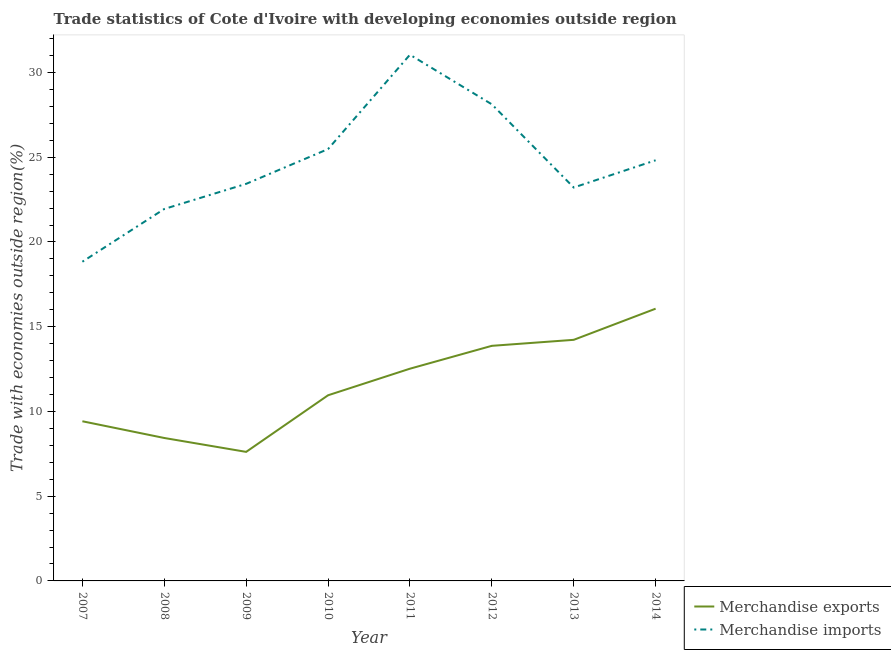How many different coloured lines are there?
Give a very brief answer. 2. Does the line corresponding to merchandise imports intersect with the line corresponding to merchandise exports?
Provide a succinct answer. No. Is the number of lines equal to the number of legend labels?
Offer a very short reply. Yes. What is the merchandise exports in 2007?
Provide a succinct answer. 9.42. Across all years, what is the maximum merchandise exports?
Give a very brief answer. 16.06. Across all years, what is the minimum merchandise imports?
Offer a very short reply. 18.84. In which year was the merchandise imports maximum?
Give a very brief answer. 2011. What is the total merchandise exports in the graph?
Make the answer very short. 93.11. What is the difference between the merchandise imports in 2007 and that in 2012?
Your response must be concise. -9.29. What is the difference between the merchandise imports in 2010 and the merchandise exports in 2011?
Keep it short and to the point. 12.96. What is the average merchandise exports per year?
Your answer should be compact. 11.64. In the year 2008, what is the difference between the merchandise imports and merchandise exports?
Your answer should be compact. 13.51. What is the ratio of the merchandise imports in 2010 to that in 2011?
Make the answer very short. 0.82. Is the difference between the merchandise imports in 2007 and 2010 greater than the difference between the merchandise exports in 2007 and 2010?
Provide a succinct answer. No. What is the difference between the highest and the second highest merchandise imports?
Your answer should be very brief. 2.93. What is the difference between the highest and the lowest merchandise imports?
Your response must be concise. 12.21. In how many years, is the merchandise imports greater than the average merchandise imports taken over all years?
Offer a terse response. 4. Is the sum of the merchandise imports in 2008 and 2012 greater than the maximum merchandise exports across all years?
Provide a short and direct response. Yes. Does the graph contain any zero values?
Offer a very short reply. No. How many legend labels are there?
Provide a succinct answer. 2. What is the title of the graph?
Your answer should be compact. Trade statistics of Cote d'Ivoire with developing economies outside region. What is the label or title of the Y-axis?
Offer a very short reply. Trade with economies outside region(%). What is the Trade with economies outside region(%) of Merchandise exports in 2007?
Provide a short and direct response. 9.42. What is the Trade with economies outside region(%) in Merchandise imports in 2007?
Offer a very short reply. 18.84. What is the Trade with economies outside region(%) in Merchandise exports in 2008?
Offer a terse response. 8.43. What is the Trade with economies outside region(%) of Merchandise imports in 2008?
Provide a succinct answer. 21.95. What is the Trade with economies outside region(%) in Merchandise exports in 2009?
Ensure brevity in your answer.  7.62. What is the Trade with economies outside region(%) in Merchandise imports in 2009?
Your answer should be compact. 23.43. What is the Trade with economies outside region(%) of Merchandise exports in 2010?
Make the answer very short. 10.96. What is the Trade with economies outside region(%) of Merchandise imports in 2010?
Your response must be concise. 25.48. What is the Trade with economies outside region(%) of Merchandise exports in 2011?
Provide a short and direct response. 12.52. What is the Trade with economies outside region(%) in Merchandise imports in 2011?
Offer a very short reply. 31.05. What is the Trade with economies outside region(%) in Merchandise exports in 2012?
Provide a succinct answer. 13.87. What is the Trade with economies outside region(%) in Merchandise imports in 2012?
Provide a succinct answer. 28.12. What is the Trade with economies outside region(%) of Merchandise exports in 2013?
Ensure brevity in your answer.  14.23. What is the Trade with economies outside region(%) in Merchandise imports in 2013?
Offer a very short reply. 23.21. What is the Trade with economies outside region(%) in Merchandise exports in 2014?
Keep it short and to the point. 16.06. What is the Trade with economies outside region(%) of Merchandise imports in 2014?
Your answer should be very brief. 24.82. Across all years, what is the maximum Trade with economies outside region(%) of Merchandise exports?
Your answer should be very brief. 16.06. Across all years, what is the maximum Trade with economies outside region(%) of Merchandise imports?
Give a very brief answer. 31.05. Across all years, what is the minimum Trade with economies outside region(%) of Merchandise exports?
Provide a short and direct response. 7.62. Across all years, what is the minimum Trade with economies outside region(%) in Merchandise imports?
Your answer should be compact. 18.84. What is the total Trade with economies outside region(%) in Merchandise exports in the graph?
Ensure brevity in your answer.  93.11. What is the total Trade with economies outside region(%) in Merchandise imports in the graph?
Make the answer very short. 196.91. What is the difference between the Trade with economies outside region(%) in Merchandise exports in 2007 and that in 2008?
Your response must be concise. 0.99. What is the difference between the Trade with economies outside region(%) of Merchandise imports in 2007 and that in 2008?
Offer a terse response. -3.11. What is the difference between the Trade with economies outside region(%) of Merchandise exports in 2007 and that in 2009?
Your answer should be compact. 1.81. What is the difference between the Trade with economies outside region(%) in Merchandise imports in 2007 and that in 2009?
Your answer should be compact. -4.6. What is the difference between the Trade with economies outside region(%) in Merchandise exports in 2007 and that in 2010?
Ensure brevity in your answer.  -1.53. What is the difference between the Trade with economies outside region(%) in Merchandise imports in 2007 and that in 2010?
Make the answer very short. -6.65. What is the difference between the Trade with economies outside region(%) in Merchandise exports in 2007 and that in 2011?
Your response must be concise. -3.1. What is the difference between the Trade with economies outside region(%) in Merchandise imports in 2007 and that in 2011?
Ensure brevity in your answer.  -12.21. What is the difference between the Trade with economies outside region(%) of Merchandise exports in 2007 and that in 2012?
Provide a short and direct response. -4.45. What is the difference between the Trade with economies outside region(%) in Merchandise imports in 2007 and that in 2012?
Keep it short and to the point. -9.29. What is the difference between the Trade with economies outside region(%) of Merchandise exports in 2007 and that in 2013?
Ensure brevity in your answer.  -4.81. What is the difference between the Trade with economies outside region(%) of Merchandise imports in 2007 and that in 2013?
Your response must be concise. -4.38. What is the difference between the Trade with economies outside region(%) in Merchandise exports in 2007 and that in 2014?
Provide a succinct answer. -6.64. What is the difference between the Trade with economies outside region(%) in Merchandise imports in 2007 and that in 2014?
Your answer should be compact. -5.99. What is the difference between the Trade with economies outside region(%) of Merchandise exports in 2008 and that in 2009?
Provide a succinct answer. 0.82. What is the difference between the Trade with economies outside region(%) in Merchandise imports in 2008 and that in 2009?
Keep it short and to the point. -1.48. What is the difference between the Trade with economies outside region(%) of Merchandise exports in 2008 and that in 2010?
Make the answer very short. -2.52. What is the difference between the Trade with economies outside region(%) in Merchandise imports in 2008 and that in 2010?
Your answer should be very brief. -3.53. What is the difference between the Trade with economies outside region(%) of Merchandise exports in 2008 and that in 2011?
Ensure brevity in your answer.  -4.09. What is the difference between the Trade with economies outside region(%) in Merchandise imports in 2008 and that in 2011?
Offer a very short reply. -9.1. What is the difference between the Trade with economies outside region(%) in Merchandise exports in 2008 and that in 2012?
Your response must be concise. -5.44. What is the difference between the Trade with economies outside region(%) of Merchandise imports in 2008 and that in 2012?
Give a very brief answer. -6.18. What is the difference between the Trade with economies outside region(%) of Merchandise exports in 2008 and that in 2013?
Keep it short and to the point. -5.79. What is the difference between the Trade with economies outside region(%) in Merchandise imports in 2008 and that in 2013?
Offer a terse response. -1.27. What is the difference between the Trade with economies outside region(%) of Merchandise exports in 2008 and that in 2014?
Ensure brevity in your answer.  -7.63. What is the difference between the Trade with economies outside region(%) in Merchandise imports in 2008 and that in 2014?
Provide a short and direct response. -2.87. What is the difference between the Trade with economies outside region(%) of Merchandise exports in 2009 and that in 2010?
Provide a succinct answer. -3.34. What is the difference between the Trade with economies outside region(%) in Merchandise imports in 2009 and that in 2010?
Provide a short and direct response. -2.05. What is the difference between the Trade with economies outside region(%) of Merchandise exports in 2009 and that in 2011?
Ensure brevity in your answer.  -4.91. What is the difference between the Trade with economies outside region(%) in Merchandise imports in 2009 and that in 2011?
Your response must be concise. -7.62. What is the difference between the Trade with economies outside region(%) in Merchandise exports in 2009 and that in 2012?
Provide a short and direct response. -6.26. What is the difference between the Trade with economies outside region(%) of Merchandise imports in 2009 and that in 2012?
Give a very brief answer. -4.69. What is the difference between the Trade with economies outside region(%) in Merchandise exports in 2009 and that in 2013?
Give a very brief answer. -6.61. What is the difference between the Trade with economies outside region(%) in Merchandise imports in 2009 and that in 2013?
Your answer should be very brief. 0.22. What is the difference between the Trade with economies outside region(%) of Merchandise exports in 2009 and that in 2014?
Your answer should be very brief. -8.45. What is the difference between the Trade with economies outside region(%) of Merchandise imports in 2009 and that in 2014?
Make the answer very short. -1.39. What is the difference between the Trade with economies outside region(%) of Merchandise exports in 2010 and that in 2011?
Provide a short and direct response. -1.57. What is the difference between the Trade with economies outside region(%) in Merchandise imports in 2010 and that in 2011?
Your response must be concise. -5.57. What is the difference between the Trade with economies outside region(%) in Merchandise exports in 2010 and that in 2012?
Keep it short and to the point. -2.92. What is the difference between the Trade with economies outside region(%) of Merchandise imports in 2010 and that in 2012?
Ensure brevity in your answer.  -2.64. What is the difference between the Trade with economies outside region(%) in Merchandise exports in 2010 and that in 2013?
Provide a short and direct response. -3.27. What is the difference between the Trade with economies outside region(%) of Merchandise imports in 2010 and that in 2013?
Ensure brevity in your answer.  2.27. What is the difference between the Trade with economies outside region(%) of Merchandise exports in 2010 and that in 2014?
Offer a very short reply. -5.11. What is the difference between the Trade with economies outside region(%) in Merchandise imports in 2010 and that in 2014?
Ensure brevity in your answer.  0.66. What is the difference between the Trade with economies outside region(%) of Merchandise exports in 2011 and that in 2012?
Offer a terse response. -1.35. What is the difference between the Trade with economies outside region(%) in Merchandise imports in 2011 and that in 2012?
Offer a very short reply. 2.93. What is the difference between the Trade with economies outside region(%) in Merchandise exports in 2011 and that in 2013?
Offer a terse response. -1.7. What is the difference between the Trade with economies outside region(%) of Merchandise imports in 2011 and that in 2013?
Offer a terse response. 7.84. What is the difference between the Trade with economies outside region(%) of Merchandise exports in 2011 and that in 2014?
Offer a very short reply. -3.54. What is the difference between the Trade with economies outside region(%) in Merchandise imports in 2011 and that in 2014?
Offer a terse response. 6.23. What is the difference between the Trade with economies outside region(%) of Merchandise exports in 2012 and that in 2013?
Give a very brief answer. -0.35. What is the difference between the Trade with economies outside region(%) in Merchandise imports in 2012 and that in 2013?
Provide a short and direct response. 4.91. What is the difference between the Trade with economies outside region(%) in Merchandise exports in 2012 and that in 2014?
Keep it short and to the point. -2.19. What is the difference between the Trade with economies outside region(%) in Merchandise imports in 2012 and that in 2014?
Your answer should be very brief. 3.3. What is the difference between the Trade with economies outside region(%) in Merchandise exports in 2013 and that in 2014?
Your answer should be very brief. -1.84. What is the difference between the Trade with economies outside region(%) in Merchandise imports in 2013 and that in 2014?
Ensure brevity in your answer.  -1.61. What is the difference between the Trade with economies outside region(%) of Merchandise exports in 2007 and the Trade with economies outside region(%) of Merchandise imports in 2008?
Your answer should be compact. -12.53. What is the difference between the Trade with economies outside region(%) in Merchandise exports in 2007 and the Trade with economies outside region(%) in Merchandise imports in 2009?
Your answer should be compact. -14.01. What is the difference between the Trade with economies outside region(%) of Merchandise exports in 2007 and the Trade with economies outside region(%) of Merchandise imports in 2010?
Offer a very short reply. -16.06. What is the difference between the Trade with economies outside region(%) of Merchandise exports in 2007 and the Trade with economies outside region(%) of Merchandise imports in 2011?
Your answer should be compact. -21.63. What is the difference between the Trade with economies outside region(%) of Merchandise exports in 2007 and the Trade with economies outside region(%) of Merchandise imports in 2012?
Your response must be concise. -18.7. What is the difference between the Trade with economies outside region(%) in Merchandise exports in 2007 and the Trade with economies outside region(%) in Merchandise imports in 2013?
Keep it short and to the point. -13.79. What is the difference between the Trade with economies outside region(%) in Merchandise exports in 2007 and the Trade with economies outside region(%) in Merchandise imports in 2014?
Your response must be concise. -15.4. What is the difference between the Trade with economies outside region(%) in Merchandise exports in 2008 and the Trade with economies outside region(%) in Merchandise imports in 2009?
Your answer should be very brief. -15. What is the difference between the Trade with economies outside region(%) of Merchandise exports in 2008 and the Trade with economies outside region(%) of Merchandise imports in 2010?
Offer a terse response. -17.05. What is the difference between the Trade with economies outside region(%) of Merchandise exports in 2008 and the Trade with economies outside region(%) of Merchandise imports in 2011?
Offer a very short reply. -22.62. What is the difference between the Trade with economies outside region(%) in Merchandise exports in 2008 and the Trade with economies outside region(%) in Merchandise imports in 2012?
Offer a very short reply. -19.69. What is the difference between the Trade with economies outside region(%) in Merchandise exports in 2008 and the Trade with economies outside region(%) in Merchandise imports in 2013?
Provide a short and direct response. -14.78. What is the difference between the Trade with economies outside region(%) in Merchandise exports in 2008 and the Trade with economies outside region(%) in Merchandise imports in 2014?
Your response must be concise. -16.39. What is the difference between the Trade with economies outside region(%) in Merchandise exports in 2009 and the Trade with economies outside region(%) in Merchandise imports in 2010?
Ensure brevity in your answer.  -17.87. What is the difference between the Trade with economies outside region(%) of Merchandise exports in 2009 and the Trade with economies outside region(%) of Merchandise imports in 2011?
Give a very brief answer. -23.44. What is the difference between the Trade with economies outside region(%) in Merchandise exports in 2009 and the Trade with economies outside region(%) in Merchandise imports in 2012?
Give a very brief answer. -20.51. What is the difference between the Trade with economies outside region(%) in Merchandise exports in 2009 and the Trade with economies outside region(%) in Merchandise imports in 2013?
Make the answer very short. -15.6. What is the difference between the Trade with economies outside region(%) of Merchandise exports in 2009 and the Trade with economies outside region(%) of Merchandise imports in 2014?
Give a very brief answer. -17.21. What is the difference between the Trade with economies outside region(%) in Merchandise exports in 2010 and the Trade with economies outside region(%) in Merchandise imports in 2011?
Your answer should be compact. -20.1. What is the difference between the Trade with economies outside region(%) of Merchandise exports in 2010 and the Trade with economies outside region(%) of Merchandise imports in 2012?
Make the answer very short. -17.17. What is the difference between the Trade with economies outside region(%) of Merchandise exports in 2010 and the Trade with economies outside region(%) of Merchandise imports in 2013?
Keep it short and to the point. -12.26. What is the difference between the Trade with economies outside region(%) in Merchandise exports in 2010 and the Trade with economies outside region(%) in Merchandise imports in 2014?
Ensure brevity in your answer.  -13.87. What is the difference between the Trade with economies outside region(%) in Merchandise exports in 2011 and the Trade with economies outside region(%) in Merchandise imports in 2012?
Offer a very short reply. -15.6. What is the difference between the Trade with economies outside region(%) in Merchandise exports in 2011 and the Trade with economies outside region(%) in Merchandise imports in 2013?
Provide a short and direct response. -10.69. What is the difference between the Trade with economies outside region(%) in Merchandise exports in 2011 and the Trade with economies outside region(%) in Merchandise imports in 2014?
Make the answer very short. -12.3. What is the difference between the Trade with economies outside region(%) of Merchandise exports in 2012 and the Trade with economies outside region(%) of Merchandise imports in 2013?
Keep it short and to the point. -9.34. What is the difference between the Trade with economies outside region(%) in Merchandise exports in 2012 and the Trade with economies outside region(%) in Merchandise imports in 2014?
Offer a very short reply. -10.95. What is the difference between the Trade with economies outside region(%) of Merchandise exports in 2013 and the Trade with economies outside region(%) of Merchandise imports in 2014?
Provide a short and direct response. -10.6. What is the average Trade with economies outside region(%) of Merchandise exports per year?
Give a very brief answer. 11.64. What is the average Trade with economies outside region(%) in Merchandise imports per year?
Ensure brevity in your answer.  24.61. In the year 2007, what is the difference between the Trade with economies outside region(%) in Merchandise exports and Trade with economies outside region(%) in Merchandise imports?
Your answer should be very brief. -9.41. In the year 2008, what is the difference between the Trade with economies outside region(%) of Merchandise exports and Trade with economies outside region(%) of Merchandise imports?
Your answer should be compact. -13.51. In the year 2009, what is the difference between the Trade with economies outside region(%) in Merchandise exports and Trade with economies outside region(%) in Merchandise imports?
Keep it short and to the point. -15.82. In the year 2010, what is the difference between the Trade with economies outside region(%) of Merchandise exports and Trade with economies outside region(%) of Merchandise imports?
Ensure brevity in your answer.  -14.53. In the year 2011, what is the difference between the Trade with economies outside region(%) of Merchandise exports and Trade with economies outside region(%) of Merchandise imports?
Make the answer very short. -18.53. In the year 2012, what is the difference between the Trade with economies outside region(%) of Merchandise exports and Trade with economies outside region(%) of Merchandise imports?
Make the answer very short. -14.25. In the year 2013, what is the difference between the Trade with economies outside region(%) of Merchandise exports and Trade with economies outside region(%) of Merchandise imports?
Your answer should be very brief. -8.99. In the year 2014, what is the difference between the Trade with economies outside region(%) in Merchandise exports and Trade with economies outside region(%) in Merchandise imports?
Your answer should be compact. -8.76. What is the ratio of the Trade with economies outside region(%) in Merchandise exports in 2007 to that in 2008?
Your answer should be compact. 1.12. What is the ratio of the Trade with economies outside region(%) in Merchandise imports in 2007 to that in 2008?
Offer a very short reply. 0.86. What is the ratio of the Trade with economies outside region(%) in Merchandise exports in 2007 to that in 2009?
Your answer should be compact. 1.24. What is the ratio of the Trade with economies outside region(%) of Merchandise imports in 2007 to that in 2009?
Your response must be concise. 0.8. What is the ratio of the Trade with economies outside region(%) of Merchandise exports in 2007 to that in 2010?
Ensure brevity in your answer.  0.86. What is the ratio of the Trade with economies outside region(%) of Merchandise imports in 2007 to that in 2010?
Provide a succinct answer. 0.74. What is the ratio of the Trade with economies outside region(%) in Merchandise exports in 2007 to that in 2011?
Provide a succinct answer. 0.75. What is the ratio of the Trade with economies outside region(%) in Merchandise imports in 2007 to that in 2011?
Your answer should be compact. 0.61. What is the ratio of the Trade with economies outside region(%) of Merchandise exports in 2007 to that in 2012?
Your response must be concise. 0.68. What is the ratio of the Trade with economies outside region(%) of Merchandise imports in 2007 to that in 2012?
Keep it short and to the point. 0.67. What is the ratio of the Trade with economies outside region(%) in Merchandise exports in 2007 to that in 2013?
Give a very brief answer. 0.66. What is the ratio of the Trade with economies outside region(%) of Merchandise imports in 2007 to that in 2013?
Offer a terse response. 0.81. What is the ratio of the Trade with economies outside region(%) in Merchandise exports in 2007 to that in 2014?
Your answer should be very brief. 0.59. What is the ratio of the Trade with economies outside region(%) of Merchandise imports in 2007 to that in 2014?
Your response must be concise. 0.76. What is the ratio of the Trade with economies outside region(%) in Merchandise exports in 2008 to that in 2009?
Your response must be concise. 1.11. What is the ratio of the Trade with economies outside region(%) in Merchandise imports in 2008 to that in 2009?
Make the answer very short. 0.94. What is the ratio of the Trade with economies outside region(%) of Merchandise exports in 2008 to that in 2010?
Your answer should be compact. 0.77. What is the ratio of the Trade with economies outside region(%) in Merchandise imports in 2008 to that in 2010?
Your response must be concise. 0.86. What is the ratio of the Trade with economies outside region(%) of Merchandise exports in 2008 to that in 2011?
Your answer should be compact. 0.67. What is the ratio of the Trade with economies outside region(%) of Merchandise imports in 2008 to that in 2011?
Provide a short and direct response. 0.71. What is the ratio of the Trade with economies outside region(%) of Merchandise exports in 2008 to that in 2012?
Your answer should be compact. 0.61. What is the ratio of the Trade with economies outside region(%) in Merchandise imports in 2008 to that in 2012?
Ensure brevity in your answer.  0.78. What is the ratio of the Trade with economies outside region(%) in Merchandise exports in 2008 to that in 2013?
Provide a succinct answer. 0.59. What is the ratio of the Trade with economies outside region(%) of Merchandise imports in 2008 to that in 2013?
Give a very brief answer. 0.95. What is the ratio of the Trade with economies outside region(%) in Merchandise exports in 2008 to that in 2014?
Give a very brief answer. 0.53. What is the ratio of the Trade with economies outside region(%) of Merchandise imports in 2008 to that in 2014?
Keep it short and to the point. 0.88. What is the ratio of the Trade with economies outside region(%) of Merchandise exports in 2009 to that in 2010?
Ensure brevity in your answer.  0.7. What is the ratio of the Trade with economies outside region(%) of Merchandise imports in 2009 to that in 2010?
Your answer should be very brief. 0.92. What is the ratio of the Trade with economies outside region(%) of Merchandise exports in 2009 to that in 2011?
Your answer should be very brief. 0.61. What is the ratio of the Trade with economies outside region(%) of Merchandise imports in 2009 to that in 2011?
Provide a succinct answer. 0.75. What is the ratio of the Trade with economies outside region(%) in Merchandise exports in 2009 to that in 2012?
Keep it short and to the point. 0.55. What is the ratio of the Trade with economies outside region(%) in Merchandise imports in 2009 to that in 2012?
Provide a short and direct response. 0.83. What is the ratio of the Trade with economies outside region(%) of Merchandise exports in 2009 to that in 2013?
Keep it short and to the point. 0.54. What is the ratio of the Trade with economies outside region(%) of Merchandise imports in 2009 to that in 2013?
Ensure brevity in your answer.  1.01. What is the ratio of the Trade with economies outside region(%) of Merchandise exports in 2009 to that in 2014?
Give a very brief answer. 0.47. What is the ratio of the Trade with economies outside region(%) in Merchandise imports in 2009 to that in 2014?
Make the answer very short. 0.94. What is the ratio of the Trade with economies outside region(%) in Merchandise exports in 2010 to that in 2011?
Keep it short and to the point. 0.87. What is the ratio of the Trade with economies outside region(%) of Merchandise imports in 2010 to that in 2011?
Your answer should be very brief. 0.82. What is the ratio of the Trade with economies outside region(%) in Merchandise exports in 2010 to that in 2012?
Your answer should be very brief. 0.79. What is the ratio of the Trade with economies outside region(%) of Merchandise imports in 2010 to that in 2012?
Keep it short and to the point. 0.91. What is the ratio of the Trade with economies outside region(%) in Merchandise exports in 2010 to that in 2013?
Provide a short and direct response. 0.77. What is the ratio of the Trade with economies outside region(%) in Merchandise imports in 2010 to that in 2013?
Give a very brief answer. 1.1. What is the ratio of the Trade with economies outside region(%) of Merchandise exports in 2010 to that in 2014?
Your answer should be compact. 0.68. What is the ratio of the Trade with economies outside region(%) in Merchandise imports in 2010 to that in 2014?
Give a very brief answer. 1.03. What is the ratio of the Trade with economies outside region(%) in Merchandise exports in 2011 to that in 2012?
Ensure brevity in your answer.  0.9. What is the ratio of the Trade with economies outside region(%) in Merchandise imports in 2011 to that in 2012?
Your answer should be very brief. 1.1. What is the ratio of the Trade with economies outside region(%) in Merchandise exports in 2011 to that in 2013?
Your answer should be compact. 0.88. What is the ratio of the Trade with economies outside region(%) of Merchandise imports in 2011 to that in 2013?
Make the answer very short. 1.34. What is the ratio of the Trade with economies outside region(%) of Merchandise exports in 2011 to that in 2014?
Your answer should be compact. 0.78. What is the ratio of the Trade with economies outside region(%) in Merchandise imports in 2011 to that in 2014?
Give a very brief answer. 1.25. What is the ratio of the Trade with economies outside region(%) of Merchandise exports in 2012 to that in 2013?
Offer a terse response. 0.98. What is the ratio of the Trade with economies outside region(%) of Merchandise imports in 2012 to that in 2013?
Offer a terse response. 1.21. What is the ratio of the Trade with economies outside region(%) of Merchandise exports in 2012 to that in 2014?
Provide a short and direct response. 0.86. What is the ratio of the Trade with economies outside region(%) of Merchandise imports in 2012 to that in 2014?
Your response must be concise. 1.13. What is the ratio of the Trade with economies outside region(%) in Merchandise exports in 2013 to that in 2014?
Ensure brevity in your answer.  0.89. What is the ratio of the Trade with economies outside region(%) in Merchandise imports in 2013 to that in 2014?
Provide a short and direct response. 0.94. What is the difference between the highest and the second highest Trade with economies outside region(%) of Merchandise exports?
Offer a terse response. 1.84. What is the difference between the highest and the second highest Trade with economies outside region(%) of Merchandise imports?
Offer a terse response. 2.93. What is the difference between the highest and the lowest Trade with economies outside region(%) in Merchandise exports?
Offer a terse response. 8.45. What is the difference between the highest and the lowest Trade with economies outside region(%) in Merchandise imports?
Make the answer very short. 12.21. 